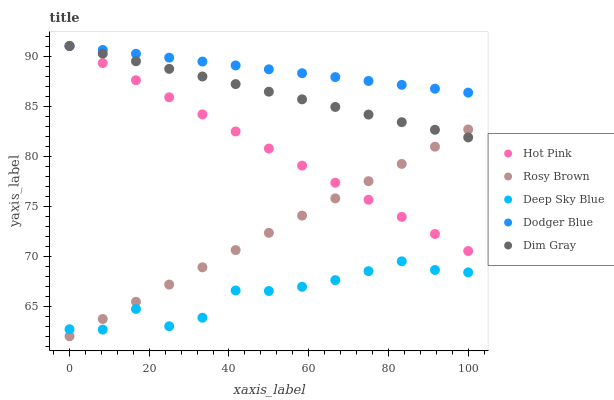Does Deep Sky Blue have the minimum area under the curve?
Answer yes or no. Yes. Does Dodger Blue have the maximum area under the curve?
Answer yes or no. Yes. Does Rosy Brown have the minimum area under the curve?
Answer yes or no. No. Does Rosy Brown have the maximum area under the curve?
Answer yes or no. No. Is Dim Gray the smoothest?
Answer yes or no. Yes. Is Deep Sky Blue the roughest?
Answer yes or no. Yes. Is Rosy Brown the smoothest?
Answer yes or no. No. Is Rosy Brown the roughest?
Answer yes or no. No. Does Rosy Brown have the lowest value?
Answer yes or no. Yes. Does Hot Pink have the lowest value?
Answer yes or no. No. Does Dodger Blue have the highest value?
Answer yes or no. Yes. Does Rosy Brown have the highest value?
Answer yes or no. No. Is Rosy Brown less than Dodger Blue?
Answer yes or no. Yes. Is Dodger Blue greater than Deep Sky Blue?
Answer yes or no. Yes. Does Hot Pink intersect Dim Gray?
Answer yes or no. Yes. Is Hot Pink less than Dim Gray?
Answer yes or no. No. Is Hot Pink greater than Dim Gray?
Answer yes or no. No. Does Rosy Brown intersect Dodger Blue?
Answer yes or no. No. 